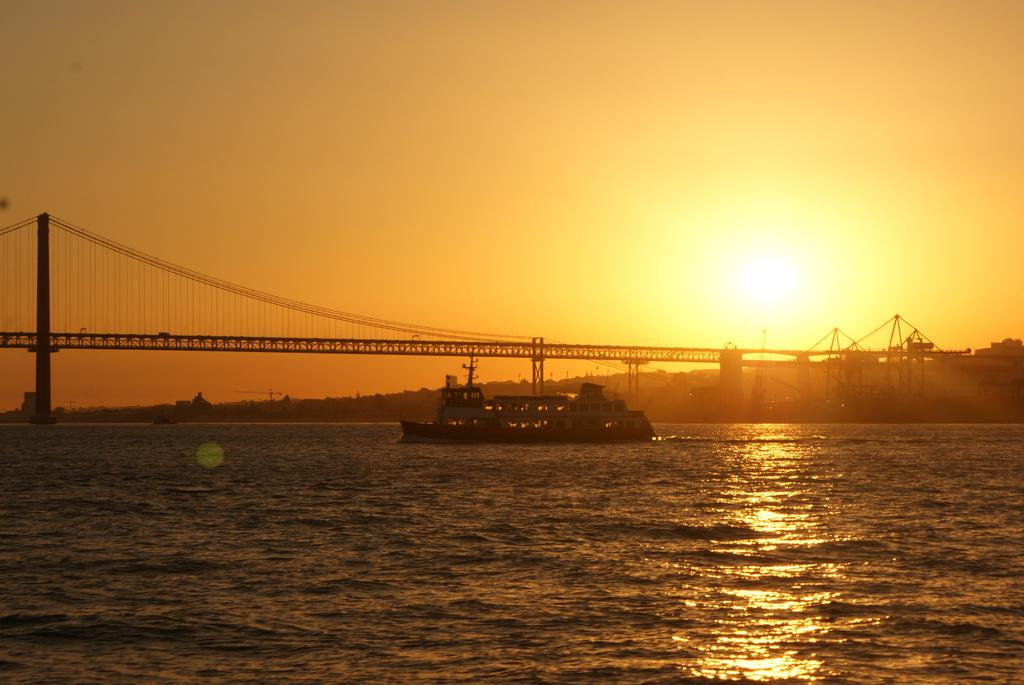What is the main subject of the image? The main subject of the image is a ship. Where is the ship located? The ship is on water. What is above the ship in the image? There is a bridge above the ship. What can be seen in the background of the image? The sky is visible in the background of the image. What decision does the office make in the image? There is no office or decision-making process depicted in the image; it features a ship on water with a bridge above it. 